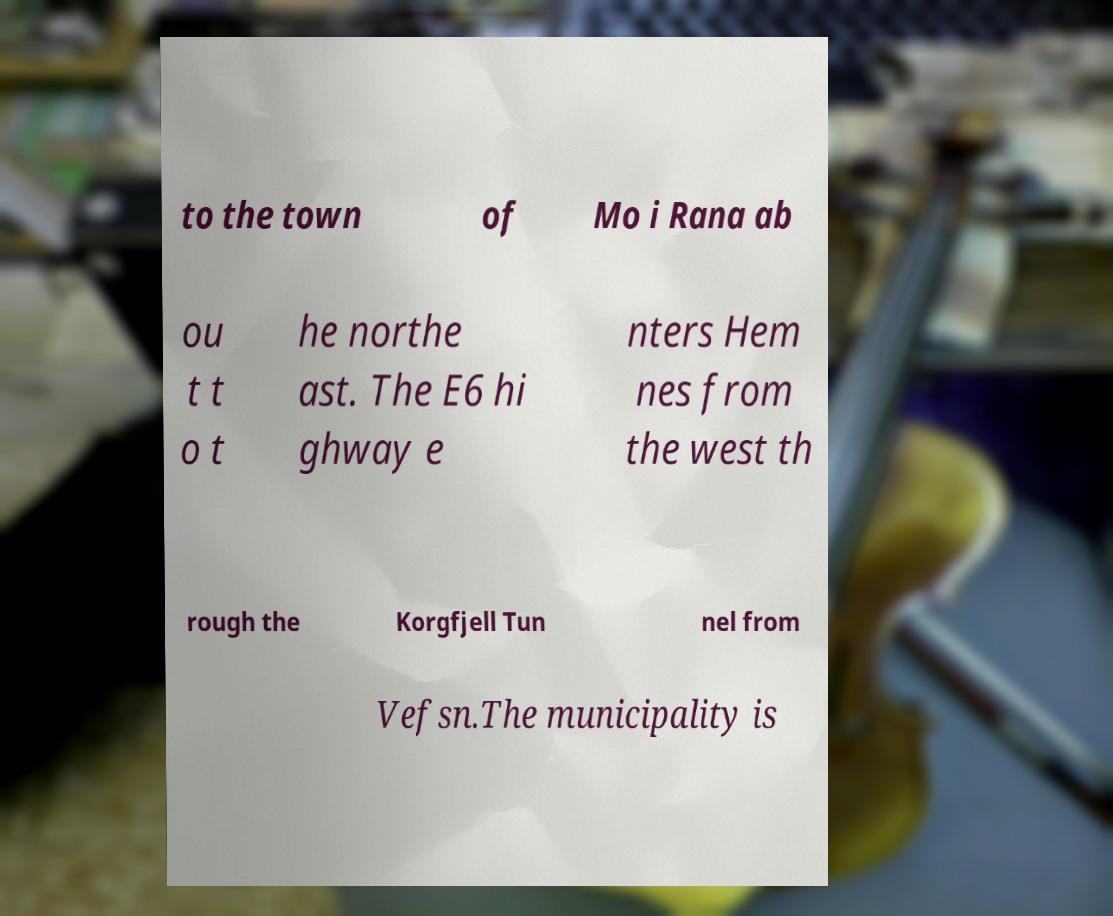Please identify and transcribe the text found in this image. to the town of Mo i Rana ab ou t t o t he northe ast. The E6 hi ghway e nters Hem nes from the west th rough the Korgfjell Tun nel from Vefsn.The municipality is 